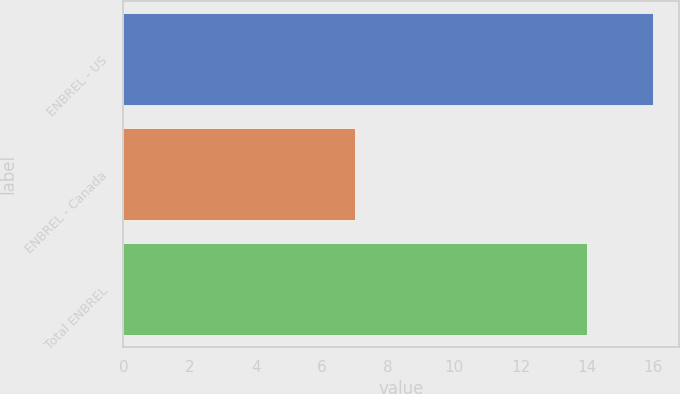Convert chart. <chart><loc_0><loc_0><loc_500><loc_500><bar_chart><fcel>ENBREL - US<fcel>ENBREL - Canada<fcel>Total ENBREL<nl><fcel>16<fcel>7<fcel>14<nl></chart> 